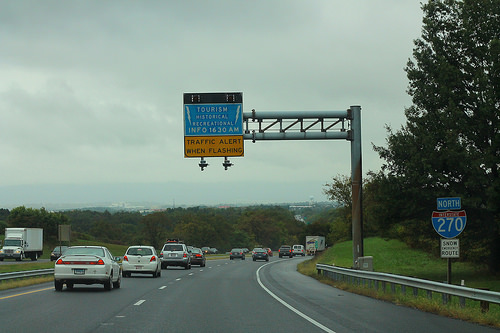<image>
Is the tree under the sky? Yes. The tree is positioned underneath the sky, with the sky above it in the vertical space. Is there a car behind the sign? Yes. From this viewpoint, the car is positioned behind the sign, with the sign partially or fully occluding the car. Is the car in the road? No. The car is not contained within the road. These objects have a different spatial relationship. 